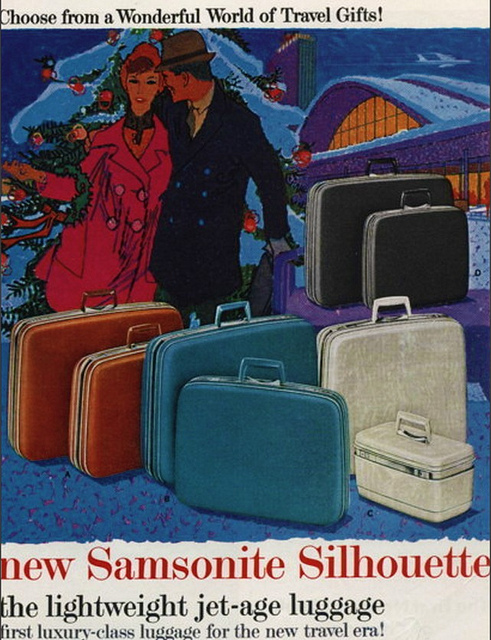How many people can be seen? 2 